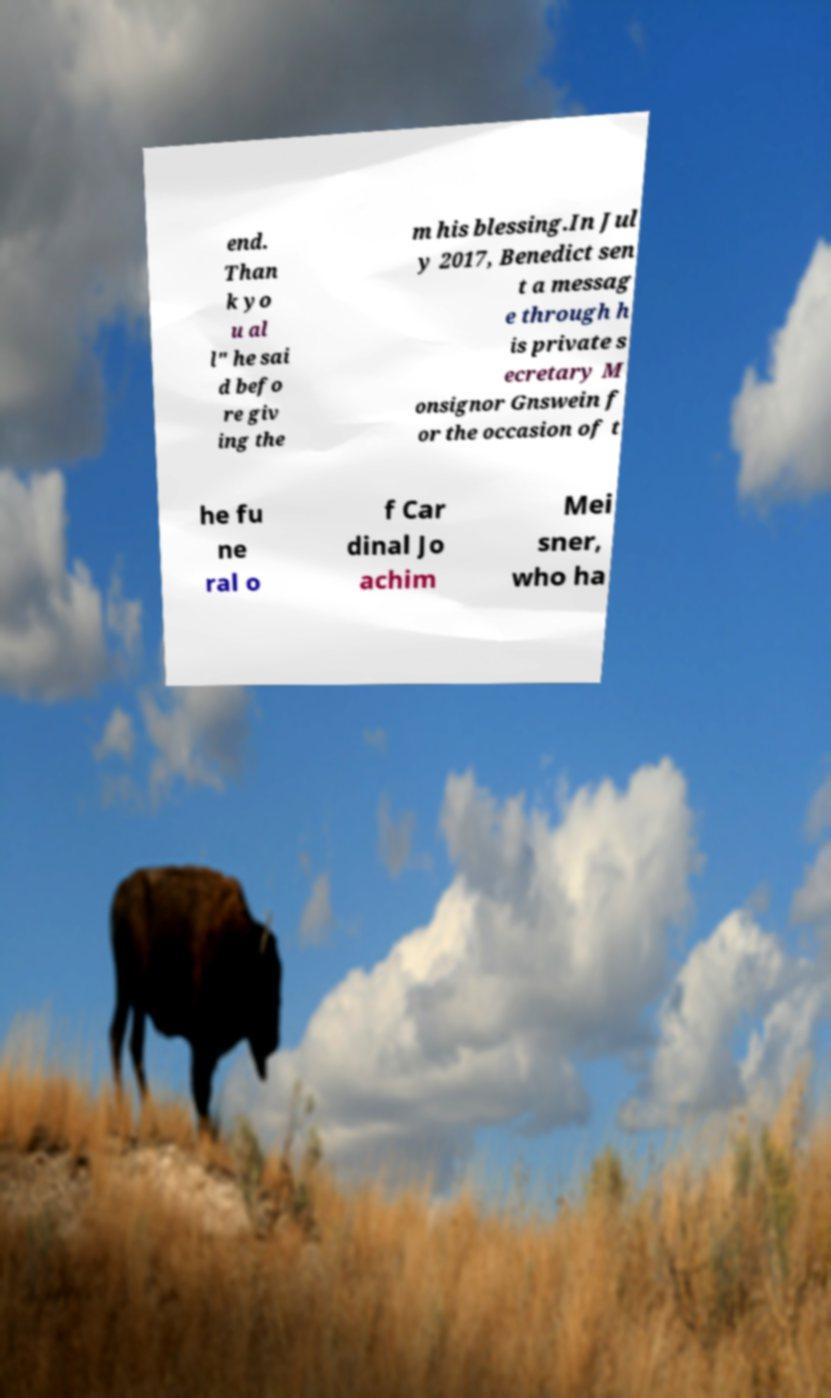There's text embedded in this image that I need extracted. Can you transcribe it verbatim? end. Than k yo u al l" he sai d befo re giv ing the m his blessing.In Jul y 2017, Benedict sen t a messag e through h is private s ecretary M onsignor Gnswein f or the occasion of t he fu ne ral o f Car dinal Jo achim Mei sner, who ha 